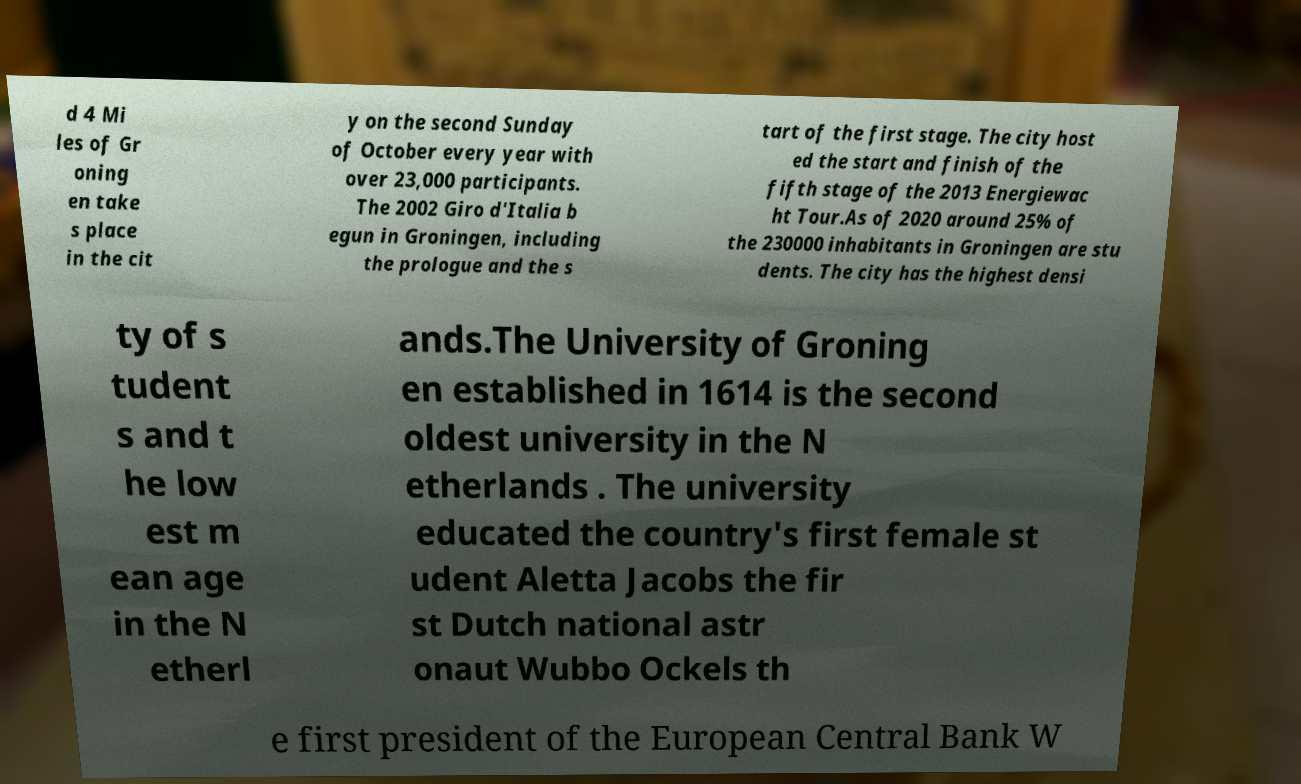Can you read and provide the text displayed in the image?This photo seems to have some interesting text. Can you extract and type it out for me? d 4 Mi les of Gr oning en take s place in the cit y on the second Sunday of October every year with over 23,000 participants. The 2002 Giro d'Italia b egun in Groningen, including the prologue and the s tart of the first stage. The city host ed the start and finish of the fifth stage of the 2013 Energiewac ht Tour.As of 2020 around 25% of the 230000 inhabitants in Groningen are stu dents. The city has the highest densi ty of s tudent s and t he low est m ean age in the N etherl ands.The University of Groning en established in 1614 is the second oldest university in the N etherlands . The university educated the country's first female st udent Aletta Jacobs the fir st Dutch national astr onaut Wubbo Ockels th e first president of the European Central Bank W 